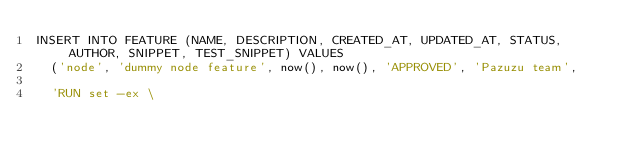Convert code to text. <code><loc_0><loc_0><loc_500><loc_500><_SQL_>INSERT INTO FEATURE (NAME, DESCRIPTION, CREATED_AT, UPDATED_AT, STATUS, AUTHOR, SNIPPET, TEST_SNIPPET) VALUES
  ('node', 'dummy node feature', now(), now(), 'APPROVED', 'Pazuzu team',

  'RUN set -ex \</code> 